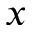<formula> <loc_0><loc_0><loc_500><loc_500>x</formula> 